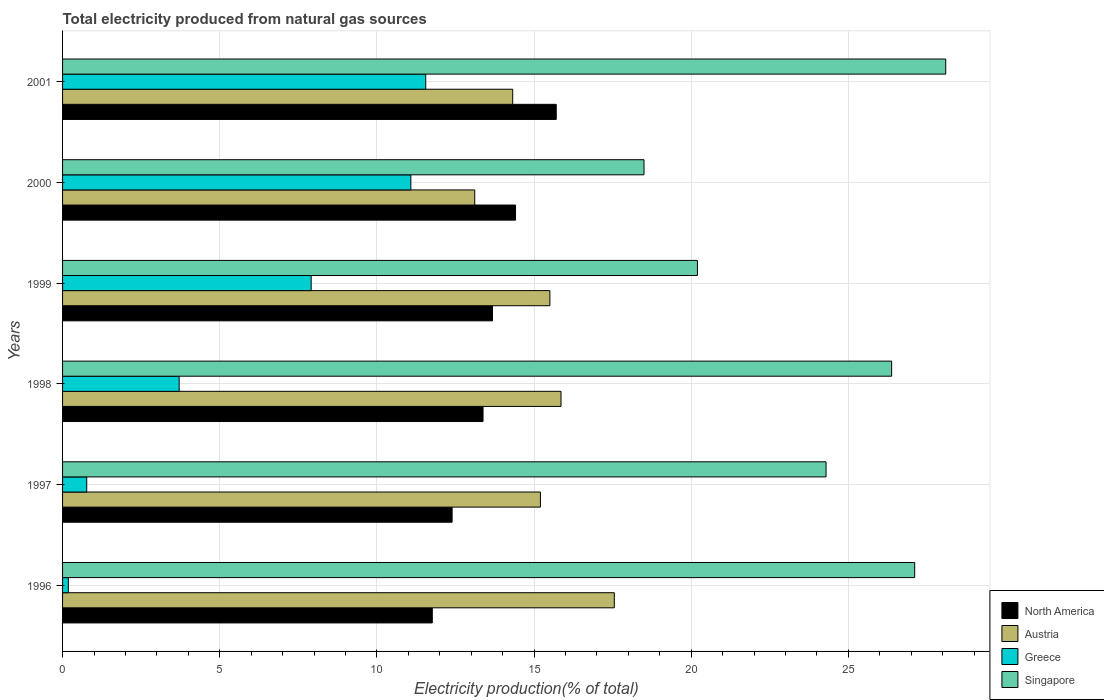How many different coloured bars are there?
Provide a succinct answer. 4. Are the number of bars per tick equal to the number of legend labels?
Offer a very short reply. Yes. Are the number of bars on each tick of the Y-axis equal?
Your answer should be compact. Yes. How many bars are there on the 6th tick from the top?
Offer a terse response. 4. What is the total electricity produced in Austria in 1996?
Provide a short and direct response. 17.56. Across all years, what is the maximum total electricity produced in Greece?
Provide a short and direct response. 11.56. Across all years, what is the minimum total electricity produced in Singapore?
Give a very brief answer. 18.5. What is the total total electricity produced in Singapore in the graph?
Your answer should be very brief. 144.58. What is the difference between the total electricity produced in Austria in 1996 and that in 1998?
Your answer should be very brief. 1.7. What is the difference between the total electricity produced in Greece in 1998 and the total electricity produced in Austria in 1999?
Provide a short and direct response. -11.8. What is the average total electricity produced in Singapore per year?
Your answer should be compact. 24.1. In the year 1998, what is the difference between the total electricity produced in Greece and total electricity produced in Singapore?
Provide a succinct answer. -22.67. In how many years, is the total electricity produced in Greece greater than 7 %?
Your answer should be compact. 3. What is the ratio of the total electricity produced in Greece in 1996 to that in 1999?
Make the answer very short. 0.02. What is the difference between the highest and the second highest total electricity produced in North America?
Offer a terse response. 1.3. What is the difference between the highest and the lowest total electricity produced in North America?
Your answer should be very brief. 3.94. In how many years, is the total electricity produced in Greece greater than the average total electricity produced in Greece taken over all years?
Your answer should be very brief. 3. Is it the case that in every year, the sum of the total electricity produced in Austria and total electricity produced in Singapore is greater than the sum of total electricity produced in North America and total electricity produced in Greece?
Your answer should be very brief. No. What does the 4th bar from the bottom in 2000 represents?
Your response must be concise. Singapore. How many bars are there?
Offer a terse response. 24. Are all the bars in the graph horizontal?
Your answer should be very brief. Yes. How many years are there in the graph?
Make the answer very short. 6. What is the difference between two consecutive major ticks on the X-axis?
Give a very brief answer. 5. Are the values on the major ticks of X-axis written in scientific E-notation?
Provide a short and direct response. No. Does the graph contain any zero values?
Offer a terse response. No. Does the graph contain grids?
Offer a very short reply. Yes. How many legend labels are there?
Provide a short and direct response. 4. How are the legend labels stacked?
Your answer should be very brief. Vertical. What is the title of the graph?
Your answer should be compact. Total electricity produced from natural gas sources. Does "High income: OECD" appear as one of the legend labels in the graph?
Your answer should be compact. No. What is the Electricity production(% of total) of North America in 1996?
Make the answer very short. 11.76. What is the Electricity production(% of total) of Austria in 1996?
Offer a very short reply. 17.56. What is the Electricity production(% of total) in Greece in 1996?
Provide a succinct answer. 0.18. What is the Electricity production(% of total) in Singapore in 1996?
Give a very brief answer. 27.11. What is the Electricity production(% of total) of North America in 1997?
Make the answer very short. 12.39. What is the Electricity production(% of total) of Austria in 1997?
Offer a very short reply. 15.2. What is the Electricity production(% of total) of Greece in 1997?
Keep it short and to the point. 0.77. What is the Electricity production(% of total) in Singapore in 1997?
Ensure brevity in your answer.  24.29. What is the Electricity production(% of total) of North America in 1998?
Your response must be concise. 13.38. What is the Electricity production(% of total) of Austria in 1998?
Offer a terse response. 15.86. What is the Electricity production(% of total) of Greece in 1998?
Keep it short and to the point. 3.71. What is the Electricity production(% of total) of Singapore in 1998?
Your answer should be compact. 26.38. What is the Electricity production(% of total) in North America in 1999?
Give a very brief answer. 13.68. What is the Electricity production(% of total) of Austria in 1999?
Your answer should be compact. 15.51. What is the Electricity production(% of total) in Greece in 1999?
Offer a very short reply. 7.91. What is the Electricity production(% of total) in Singapore in 1999?
Offer a very short reply. 20.2. What is the Electricity production(% of total) of North America in 2000?
Give a very brief answer. 14.41. What is the Electricity production(% of total) in Austria in 2000?
Your answer should be very brief. 13.11. What is the Electricity production(% of total) of Greece in 2000?
Give a very brief answer. 11.08. What is the Electricity production(% of total) of Singapore in 2000?
Ensure brevity in your answer.  18.5. What is the Electricity production(% of total) of North America in 2001?
Keep it short and to the point. 15.71. What is the Electricity production(% of total) in Austria in 2001?
Your answer should be very brief. 14.32. What is the Electricity production(% of total) of Greece in 2001?
Your response must be concise. 11.56. What is the Electricity production(% of total) in Singapore in 2001?
Provide a succinct answer. 28.1. Across all years, what is the maximum Electricity production(% of total) of North America?
Your answer should be compact. 15.71. Across all years, what is the maximum Electricity production(% of total) of Austria?
Make the answer very short. 17.56. Across all years, what is the maximum Electricity production(% of total) in Greece?
Make the answer very short. 11.56. Across all years, what is the maximum Electricity production(% of total) of Singapore?
Offer a terse response. 28.1. Across all years, what is the minimum Electricity production(% of total) of North America?
Ensure brevity in your answer.  11.76. Across all years, what is the minimum Electricity production(% of total) in Austria?
Give a very brief answer. 13.11. Across all years, what is the minimum Electricity production(% of total) of Greece?
Offer a very short reply. 0.18. Across all years, what is the minimum Electricity production(% of total) in Singapore?
Your answer should be very brief. 18.5. What is the total Electricity production(% of total) of North America in the graph?
Offer a terse response. 81.33. What is the total Electricity production(% of total) of Austria in the graph?
Your answer should be very brief. 91.56. What is the total Electricity production(% of total) of Greece in the graph?
Provide a succinct answer. 35.21. What is the total Electricity production(% of total) of Singapore in the graph?
Provide a short and direct response. 144.58. What is the difference between the Electricity production(% of total) of North America in 1996 and that in 1997?
Offer a terse response. -0.63. What is the difference between the Electricity production(% of total) of Austria in 1996 and that in 1997?
Ensure brevity in your answer.  2.35. What is the difference between the Electricity production(% of total) of Greece in 1996 and that in 1997?
Provide a short and direct response. -0.59. What is the difference between the Electricity production(% of total) in Singapore in 1996 and that in 1997?
Offer a terse response. 2.82. What is the difference between the Electricity production(% of total) of North America in 1996 and that in 1998?
Your answer should be very brief. -1.61. What is the difference between the Electricity production(% of total) of Austria in 1996 and that in 1998?
Your answer should be compact. 1.7. What is the difference between the Electricity production(% of total) of Greece in 1996 and that in 1998?
Your response must be concise. -3.53. What is the difference between the Electricity production(% of total) in Singapore in 1996 and that in 1998?
Your response must be concise. 0.73. What is the difference between the Electricity production(% of total) in North America in 1996 and that in 1999?
Provide a succinct answer. -1.92. What is the difference between the Electricity production(% of total) in Austria in 1996 and that in 1999?
Your response must be concise. 2.05. What is the difference between the Electricity production(% of total) in Greece in 1996 and that in 1999?
Provide a short and direct response. -7.73. What is the difference between the Electricity production(% of total) in Singapore in 1996 and that in 1999?
Your answer should be very brief. 6.91. What is the difference between the Electricity production(% of total) of North America in 1996 and that in 2000?
Offer a very short reply. -2.65. What is the difference between the Electricity production(% of total) of Austria in 1996 and that in 2000?
Make the answer very short. 4.44. What is the difference between the Electricity production(% of total) of Greece in 1996 and that in 2000?
Offer a terse response. -10.9. What is the difference between the Electricity production(% of total) of Singapore in 1996 and that in 2000?
Ensure brevity in your answer.  8.61. What is the difference between the Electricity production(% of total) of North America in 1996 and that in 2001?
Keep it short and to the point. -3.94. What is the difference between the Electricity production(% of total) in Austria in 1996 and that in 2001?
Offer a very short reply. 3.23. What is the difference between the Electricity production(% of total) in Greece in 1996 and that in 2001?
Offer a very short reply. -11.37. What is the difference between the Electricity production(% of total) in Singapore in 1996 and that in 2001?
Give a very brief answer. -0.99. What is the difference between the Electricity production(% of total) in North America in 1997 and that in 1998?
Offer a terse response. -0.98. What is the difference between the Electricity production(% of total) of Austria in 1997 and that in 1998?
Ensure brevity in your answer.  -0.66. What is the difference between the Electricity production(% of total) of Greece in 1997 and that in 1998?
Give a very brief answer. -2.94. What is the difference between the Electricity production(% of total) in Singapore in 1997 and that in 1998?
Offer a terse response. -2.09. What is the difference between the Electricity production(% of total) in North America in 1997 and that in 1999?
Make the answer very short. -1.29. What is the difference between the Electricity production(% of total) in Austria in 1997 and that in 1999?
Offer a terse response. -0.3. What is the difference between the Electricity production(% of total) in Greece in 1997 and that in 1999?
Offer a very short reply. -7.14. What is the difference between the Electricity production(% of total) of Singapore in 1997 and that in 1999?
Provide a succinct answer. 4.09. What is the difference between the Electricity production(% of total) of North America in 1997 and that in 2000?
Keep it short and to the point. -2.02. What is the difference between the Electricity production(% of total) of Austria in 1997 and that in 2000?
Keep it short and to the point. 2.09. What is the difference between the Electricity production(% of total) in Greece in 1997 and that in 2000?
Provide a short and direct response. -10.31. What is the difference between the Electricity production(% of total) of Singapore in 1997 and that in 2000?
Your response must be concise. 5.79. What is the difference between the Electricity production(% of total) in North America in 1997 and that in 2001?
Provide a succinct answer. -3.31. What is the difference between the Electricity production(% of total) of Austria in 1997 and that in 2001?
Keep it short and to the point. 0.88. What is the difference between the Electricity production(% of total) of Greece in 1997 and that in 2001?
Keep it short and to the point. -10.79. What is the difference between the Electricity production(% of total) in Singapore in 1997 and that in 2001?
Ensure brevity in your answer.  -3.81. What is the difference between the Electricity production(% of total) of North America in 1998 and that in 1999?
Your answer should be very brief. -0.3. What is the difference between the Electricity production(% of total) of Austria in 1998 and that in 1999?
Offer a very short reply. 0.35. What is the difference between the Electricity production(% of total) in Greece in 1998 and that in 1999?
Provide a short and direct response. -4.2. What is the difference between the Electricity production(% of total) of Singapore in 1998 and that in 1999?
Your answer should be compact. 6.18. What is the difference between the Electricity production(% of total) in North America in 1998 and that in 2000?
Offer a terse response. -1.03. What is the difference between the Electricity production(% of total) in Austria in 1998 and that in 2000?
Provide a succinct answer. 2.75. What is the difference between the Electricity production(% of total) of Greece in 1998 and that in 2000?
Your response must be concise. -7.37. What is the difference between the Electricity production(% of total) in Singapore in 1998 and that in 2000?
Your answer should be compact. 7.88. What is the difference between the Electricity production(% of total) of North America in 1998 and that in 2001?
Provide a succinct answer. -2.33. What is the difference between the Electricity production(% of total) of Austria in 1998 and that in 2001?
Make the answer very short. 1.54. What is the difference between the Electricity production(% of total) in Greece in 1998 and that in 2001?
Offer a terse response. -7.85. What is the difference between the Electricity production(% of total) in Singapore in 1998 and that in 2001?
Keep it short and to the point. -1.72. What is the difference between the Electricity production(% of total) in North America in 1999 and that in 2000?
Ensure brevity in your answer.  -0.73. What is the difference between the Electricity production(% of total) of Austria in 1999 and that in 2000?
Ensure brevity in your answer.  2.39. What is the difference between the Electricity production(% of total) of Greece in 1999 and that in 2000?
Offer a very short reply. -3.17. What is the difference between the Electricity production(% of total) of Singapore in 1999 and that in 2000?
Keep it short and to the point. 1.7. What is the difference between the Electricity production(% of total) of North America in 1999 and that in 2001?
Ensure brevity in your answer.  -2.03. What is the difference between the Electricity production(% of total) of Austria in 1999 and that in 2001?
Ensure brevity in your answer.  1.18. What is the difference between the Electricity production(% of total) in Greece in 1999 and that in 2001?
Your answer should be very brief. -3.65. What is the difference between the Electricity production(% of total) in Singapore in 1999 and that in 2001?
Provide a short and direct response. -7.9. What is the difference between the Electricity production(% of total) in North America in 2000 and that in 2001?
Give a very brief answer. -1.3. What is the difference between the Electricity production(% of total) in Austria in 2000 and that in 2001?
Your response must be concise. -1.21. What is the difference between the Electricity production(% of total) in Greece in 2000 and that in 2001?
Your answer should be very brief. -0.47. What is the difference between the Electricity production(% of total) of Singapore in 2000 and that in 2001?
Ensure brevity in your answer.  -9.6. What is the difference between the Electricity production(% of total) of North America in 1996 and the Electricity production(% of total) of Austria in 1997?
Keep it short and to the point. -3.44. What is the difference between the Electricity production(% of total) in North America in 1996 and the Electricity production(% of total) in Greece in 1997?
Make the answer very short. 10.99. What is the difference between the Electricity production(% of total) of North America in 1996 and the Electricity production(% of total) of Singapore in 1997?
Give a very brief answer. -12.53. What is the difference between the Electricity production(% of total) in Austria in 1996 and the Electricity production(% of total) in Greece in 1997?
Your answer should be compact. 16.79. What is the difference between the Electricity production(% of total) in Austria in 1996 and the Electricity production(% of total) in Singapore in 1997?
Provide a short and direct response. -6.74. What is the difference between the Electricity production(% of total) in Greece in 1996 and the Electricity production(% of total) in Singapore in 1997?
Give a very brief answer. -24.11. What is the difference between the Electricity production(% of total) of North America in 1996 and the Electricity production(% of total) of Austria in 1998?
Offer a very short reply. -4.1. What is the difference between the Electricity production(% of total) in North America in 1996 and the Electricity production(% of total) in Greece in 1998?
Make the answer very short. 8.05. What is the difference between the Electricity production(% of total) of North America in 1996 and the Electricity production(% of total) of Singapore in 1998?
Give a very brief answer. -14.62. What is the difference between the Electricity production(% of total) in Austria in 1996 and the Electricity production(% of total) in Greece in 1998?
Offer a very short reply. 13.85. What is the difference between the Electricity production(% of total) in Austria in 1996 and the Electricity production(% of total) in Singapore in 1998?
Provide a succinct answer. -8.82. What is the difference between the Electricity production(% of total) of Greece in 1996 and the Electricity production(% of total) of Singapore in 1998?
Keep it short and to the point. -26.19. What is the difference between the Electricity production(% of total) of North America in 1996 and the Electricity production(% of total) of Austria in 1999?
Ensure brevity in your answer.  -3.74. What is the difference between the Electricity production(% of total) in North America in 1996 and the Electricity production(% of total) in Greece in 1999?
Your answer should be compact. 3.85. What is the difference between the Electricity production(% of total) in North America in 1996 and the Electricity production(% of total) in Singapore in 1999?
Ensure brevity in your answer.  -8.44. What is the difference between the Electricity production(% of total) of Austria in 1996 and the Electricity production(% of total) of Greece in 1999?
Keep it short and to the point. 9.65. What is the difference between the Electricity production(% of total) of Austria in 1996 and the Electricity production(% of total) of Singapore in 1999?
Ensure brevity in your answer.  -2.64. What is the difference between the Electricity production(% of total) of Greece in 1996 and the Electricity production(% of total) of Singapore in 1999?
Your response must be concise. -20.02. What is the difference between the Electricity production(% of total) in North America in 1996 and the Electricity production(% of total) in Austria in 2000?
Ensure brevity in your answer.  -1.35. What is the difference between the Electricity production(% of total) of North America in 1996 and the Electricity production(% of total) of Greece in 2000?
Make the answer very short. 0.68. What is the difference between the Electricity production(% of total) in North America in 1996 and the Electricity production(% of total) in Singapore in 2000?
Offer a very short reply. -6.74. What is the difference between the Electricity production(% of total) in Austria in 1996 and the Electricity production(% of total) in Greece in 2000?
Offer a terse response. 6.47. What is the difference between the Electricity production(% of total) of Austria in 1996 and the Electricity production(% of total) of Singapore in 2000?
Provide a succinct answer. -0.94. What is the difference between the Electricity production(% of total) in Greece in 1996 and the Electricity production(% of total) in Singapore in 2000?
Offer a very short reply. -18.32. What is the difference between the Electricity production(% of total) of North America in 1996 and the Electricity production(% of total) of Austria in 2001?
Provide a short and direct response. -2.56. What is the difference between the Electricity production(% of total) in North America in 1996 and the Electricity production(% of total) in Greece in 2001?
Ensure brevity in your answer.  0.21. What is the difference between the Electricity production(% of total) of North America in 1996 and the Electricity production(% of total) of Singapore in 2001?
Provide a succinct answer. -16.34. What is the difference between the Electricity production(% of total) in Austria in 1996 and the Electricity production(% of total) in Greece in 2001?
Your answer should be compact. 6. What is the difference between the Electricity production(% of total) of Austria in 1996 and the Electricity production(% of total) of Singapore in 2001?
Your answer should be compact. -10.54. What is the difference between the Electricity production(% of total) of Greece in 1996 and the Electricity production(% of total) of Singapore in 2001?
Your answer should be very brief. -27.92. What is the difference between the Electricity production(% of total) in North America in 1997 and the Electricity production(% of total) in Austria in 1998?
Provide a succinct answer. -3.47. What is the difference between the Electricity production(% of total) in North America in 1997 and the Electricity production(% of total) in Greece in 1998?
Provide a succinct answer. 8.68. What is the difference between the Electricity production(% of total) of North America in 1997 and the Electricity production(% of total) of Singapore in 1998?
Offer a terse response. -13.98. What is the difference between the Electricity production(% of total) of Austria in 1997 and the Electricity production(% of total) of Greece in 1998?
Ensure brevity in your answer.  11.49. What is the difference between the Electricity production(% of total) in Austria in 1997 and the Electricity production(% of total) in Singapore in 1998?
Provide a succinct answer. -11.18. What is the difference between the Electricity production(% of total) of Greece in 1997 and the Electricity production(% of total) of Singapore in 1998?
Provide a short and direct response. -25.61. What is the difference between the Electricity production(% of total) in North America in 1997 and the Electricity production(% of total) in Austria in 1999?
Your answer should be very brief. -3.11. What is the difference between the Electricity production(% of total) of North America in 1997 and the Electricity production(% of total) of Greece in 1999?
Ensure brevity in your answer.  4.48. What is the difference between the Electricity production(% of total) of North America in 1997 and the Electricity production(% of total) of Singapore in 1999?
Provide a succinct answer. -7.81. What is the difference between the Electricity production(% of total) in Austria in 1997 and the Electricity production(% of total) in Greece in 1999?
Give a very brief answer. 7.29. What is the difference between the Electricity production(% of total) in Austria in 1997 and the Electricity production(% of total) in Singapore in 1999?
Make the answer very short. -5. What is the difference between the Electricity production(% of total) of Greece in 1997 and the Electricity production(% of total) of Singapore in 1999?
Provide a short and direct response. -19.43. What is the difference between the Electricity production(% of total) in North America in 1997 and the Electricity production(% of total) in Austria in 2000?
Make the answer very short. -0.72. What is the difference between the Electricity production(% of total) in North America in 1997 and the Electricity production(% of total) in Greece in 2000?
Provide a succinct answer. 1.31. What is the difference between the Electricity production(% of total) of North America in 1997 and the Electricity production(% of total) of Singapore in 2000?
Your answer should be very brief. -6.11. What is the difference between the Electricity production(% of total) in Austria in 1997 and the Electricity production(% of total) in Greece in 2000?
Ensure brevity in your answer.  4.12. What is the difference between the Electricity production(% of total) in Austria in 1997 and the Electricity production(% of total) in Singapore in 2000?
Offer a very short reply. -3.3. What is the difference between the Electricity production(% of total) of Greece in 1997 and the Electricity production(% of total) of Singapore in 2000?
Make the answer very short. -17.73. What is the difference between the Electricity production(% of total) of North America in 1997 and the Electricity production(% of total) of Austria in 2001?
Provide a succinct answer. -1.93. What is the difference between the Electricity production(% of total) of North America in 1997 and the Electricity production(% of total) of Greece in 2001?
Your answer should be compact. 0.84. What is the difference between the Electricity production(% of total) of North America in 1997 and the Electricity production(% of total) of Singapore in 2001?
Offer a terse response. -15.71. What is the difference between the Electricity production(% of total) of Austria in 1997 and the Electricity production(% of total) of Greece in 2001?
Keep it short and to the point. 3.65. What is the difference between the Electricity production(% of total) in Austria in 1997 and the Electricity production(% of total) in Singapore in 2001?
Your response must be concise. -12.9. What is the difference between the Electricity production(% of total) in Greece in 1997 and the Electricity production(% of total) in Singapore in 2001?
Your response must be concise. -27.33. What is the difference between the Electricity production(% of total) in North America in 1998 and the Electricity production(% of total) in Austria in 1999?
Make the answer very short. -2.13. What is the difference between the Electricity production(% of total) in North America in 1998 and the Electricity production(% of total) in Greece in 1999?
Offer a very short reply. 5.47. What is the difference between the Electricity production(% of total) in North America in 1998 and the Electricity production(% of total) in Singapore in 1999?
Provide a succinct answer. -6.82. What is the difference between the Electricity production(% of total) of Austria in 1998 and the Electricity production(% of total) of Greece in 1999?
Provide a short and direct response. 7.95. What is the difference between the Electricity production(% of total) in Austria in 1998 and the Electricity production(% of total) in Singapore in 1999?
Make the answer very short. -4.34. What is the difference between the Electricity production(% of total) of Greece in 1998 and the Electricity production(% of total) of Singapore in 1999?
Keep it short and to the point. -16.49. What is the difference between the Electricity production(% of total) in North America in 1998 and the Electricity production(% of total) in Austria in 2000?
Ensure brevity in your answer.  0.26. What is the difference between the Electricity production(% of total) in North America in 1998 and the Electricity production(% of total) in Greece in 2000?
Ensure brevity in your answer.  2.3. What is the difference between the Electricity production(% of total) of North America in 1998 and the Electricity production(% of total) of Singapore in 2000?
Make the answer very short. -5.12. What is the difference between the Electricity production(% of total) in Austria in 1998 and the Electricity production(% of total) in Greece in 2000?
Provide a succinct answer. 4.78. What is the difference between the Electricity production(% of total) in Austria in 1998 and the Electricity production(% of total) in Singapore in 2000?
Offer a very short reply. -2.64. What is the difference between the Electricity production(% of total) in Greece in 1998 and the Electricity production(% of total) in Singapore in 2000?
Provide a succinct answer. -14.79. What is the difference between the Electricity production(% of total) of North America in 1998 and the Electricity production(% of total) of Austria in 2001?
Provide a succinct answer. -0.94. What is the difference between the Electricity production(% of total) of North America in 1998 and the Electricity production(% of total) of Greece in 2001?
Keep it short and to the point. 1.82. What is the difference between the Electricity production(% of total) in North America in 1998 and the Electricity production(% of total) in Singapore in 2001?
Your response must be concise. -14.72. What is the difference between the Electricity production(% of total) in Austria in 1998 and the Electricity production(% of total) in Greece in 2001?
Make the answer very short. 4.3. What is the difference between the Electricity production(% of total) in Austria in 1998 and the Electricity production(% of total) in Singapore in 2001?
Offer a very short reply. -12.24. What is the difference between the Electricity production(% of total) of Greece in 1998 and the Electricity production(% of total) of Singapore in 2001?
Ensure brevity in your answer.  -24.39. What is the difference between the Electricity production(% of total) of North America in 1999 and the Electricity production(% of total) of Austria in 2000?
Keep it short and to the point. 0.57. What is the difference between the Electricity production(% of total) of North America in 1999 and the Electricity production(% of total) of Greece in 2000?
Make the answer very short. 2.6. What is the difference between the Electricity production(% of total) of North America in 1999 and the Electricity production(% of total) of Singapore in 2000?
Offer a very short reply. -4.82. What is the difference between the Electricity production(% of total) in Austria in 1999 and the Electricity production(% of total) in Greece in 2000?
Your answer should be very brief. 4.42. What is the difference between the Electricity production(% of total) of Austria in 1999 and the Electricity production(% of total) of Singapore in 2000?
Your answer should be very brief. -2.99. What is the difference between the Electricity production(% of total) in Greece in 1999 and the Electricity production(% of total) in Singapore in 2000?
Offer a terse response. -10.59. What is the difference between the Electricity production(% of total) in North America in 1999 and the Electricity production(% of total) in Austria in 2001?
Keep it short and to the point. -0.64. What is the difference between the Electricity production(% of total) of North America in 1999 and the Electricity production(% of total) of Greece in 2001?
Give a very brief answer. 2.12. What is the difference between the Electricity production(% of total) of North America in 1999 and the Electricity production(% of total) of Singapore in 2001?
Ensure brevity in your answer.  -14.42. What is the difference between the Electricity production(% of total) of Austria in 1999 and the Electricity production(% of total) of Greece in 2001?
Your response must be concise. 3.95. What is the difference between the Electricity production(% of total) of Austria in 1999 and the Electricity production(% of total) of Singapore in 2001?
Provide a short and direct response. -12.59. What is the difference between the Electricity production(% of total) of Greece in 1999 and the Electricity production(% of total) of Singapore in 2001?
Make the answer very short. -20.19. What is the difference between the Electricity production(% of total) in North America in 2000 and the Electricity production(% of total) in Austria in 2001?
Make the answer very short. 0.09. What is the difference between the Electricity production(% of total) in North America in 2000 and the Electricity production(% of total) in Greece in 2001?
Keep it short and to the point. 2.86. What is the difference between the Electricity production(% of total) of North America in 2000 and the Electricity production(% of total) of Singapore in 2001?
Keep it short and to the point. -13.69. What is the difference between the Electricity production(% of total) in Austria in 2000 and the Electricity production(% of total) in Greece in 2001?
Give a very brief answer. 1.56. What is the difference between the Electricity production(% of total) in Austria in 2000 and the Electricity production(% of total) in Singapore in 2001?
Give a very brief answer. -14.99. What is the difference between the Electricity production(% of total) in Greece in 2000 and the Electricity production(% of total) in Singapore in 2001?
Your answer should be very brief. -17.02. What is the average Electricity production(% of total) of North America per year?
Provide a succinct answer. 13.56. What is the average Electricity production(% of total) in Austria per year?
Provide a succinct answer. 15.26. What is the average Electricity production(% of total) of Greece per year?
Give a very brief answer. 5.87. What is the average Electricity production(% of total) of Singapore per year?
Ensure brevity in your answer.  24.1. In the year 1996, what is the difference between the Electricity production(% of total) in North America and Electricity production(% of total) in Austria?
Provide a short and direct response. -5.79. In the year 1996, what is the difference between the Electricity production(% of total) of North America and Electricity production(% of total) of Greece?
Keep it short and to the point. 11.58. In the year 1996, what is the difference between the Electricity production(% of total) of North America and Electricity production(% of total) of Singapore?
Your answer should be very brief. -15.35. In the year 1996, what is the difference between the Electricity production(% of total) in Austria and Electricity production(% of total) in Greece?
Your answer should be compact. 17.37. In the year 1996, what is the difference between the Electricity production(% of total) in Austria and Electricity production(% of total) in Singapore?
Your answer should be very brief. -9.56. In the year 1996, what is the difference between the Electricity production(% of total) of Greece and Electricity production(% of total) of Singapore?
Your answer should be very brief. -26.93. In the year 1997, what is the difference between the Electricity production(% of total) in North America and Electricity production(% of total) in Austria?
Your answer should be compact. -2.81. In the year 1997, what is the difference between the Electricity production(% of total) in North America and Electricity production(% of total) in Greece?
Provide a short and direct response. 11.62. In the year 1997, what is the difference between the Electricity production(% of total) of North America and Electricity production(% of total) of Singapore?
Make the answer very short. -11.9. In the year 1997, what is the difference between the Electricity production(% of total) in Austria and Electricity production(% of total) in Greece?
Your response must be concise. 14.43. In the year 1997, what is the difference between the Electricity production(% of total) in Austria and Electricity production(% of total) in Singapore?
Keep it short and to the point. -9.09. In the year 1997, what is the difference between the Electricity production(% of total) in Greece and Electricity production(% of total) in Singapore?
Provide a short and direct response. -23.52. In the year 1998, what is the difference between the Electricity production(% of total) of North America and Electricity production(% of total) of Austria?
Offer a terse response. -2.48. In the year 1998, what is the difference between the Electricity production(% of total) in North America and Electricity production(% of total) in Greece?
Offer a very short reply. 9.67. In the year 1998, what is the difference between the Electricity production(% of total) in North America and Electricity production(% of total) in Singapore?
Provide a short and direct response. -13. In the year 1998, what is the difference between the Electricity production(% of total) of Austria and Electricity production(% of total) of Greece?
Make the answer very short. 12.15. In the year 1998, what is the difference between the Electricity production(% of total) in Austria and Electricity production(% of total) in Singapore?
Make the answer very short. -10.52. In the year 1998, what is the difference between the Electricity production(% of total) in Greece and Electricity production(% of total) in Singapore?
Ensure brevity in your answer.  -22.67. In the year 1999, what is the difference between the Electricity production(% of total) in North America and Electricity production(% of total) in Austria?
Provide a short and direct response. -1.83. In the year 1999, what is the difference between the Electricity production(% of total) in North America and Electricity production(% of total) in Greece?
Offer a terse response. 5.77. In the year 1999, what is the difference between the Electricity production(% of total) of North America and Electricity production(% of total) of Singapore?
Offer a terse response. -6.52. In the year 1999, what is the difference between the Electricity production(% of total) in Austria and Electricity production(% of total) in Greece?
Give a very brief answer. 7.6. In the year 1999, what is the difference between the Electricity production(% of total) of Austria and Electricity production(% of total) of Singapore?
Your answer should be very brief. -4.69. In the year 1999, what is the difference between the Electricity production(% of total) in Greece and Electricity production(% of total) in Singapore?
Offer a very short reply. -12.29. In the year 2000, what is the difference between the Electricity production(% of total) of North America and Electricity production(% of total) of Austria?
Give a very brief answer. 1.3. In the year 2000, what is the difference between the Electricity production(% of total) in North America and Electricity production(% of total) in Greece?
Make the answer very short. 3.33. In the year 2000, what is the difference between the Electricity production(% of total) in North America and Electricity production(% of total) in Singapore?
Offer a terse response. -4.09. In the year 2000, what is the difference between the Electricity production(% of total) of Austria and Electricity production(% of total) of Greece?
Keep it short and to the point. 2.03. In the year 2000, what is the difference between the Electricity production(% of total) in Austria and Electricity production(% of total) in Singapore?
Offer a terse response. -5.39. In the year 2000, what is the difference between the Electricity production(% of total) in Greece and Electricity production(% of total) in Singapore?
Provide a succinct answer. -7.42. In the year 2001, what is the difference between the Electricity production(% of total) in North America and Electricity production(% of total) in Austria?
Make the answer very short. 1.39. In the year 2001, what is the difference between the Electricity production(% of total) in North America and Electricity production(% of total) in Greece?
Ensure brevity in your answer.  4.15. In the year 2001, what is the difference between the Electricity production(% of total) of North America and Electricity production(% of total) of Singapore?
Your response must be concise. -12.39. In the year 2001, what is the difference between the Electricity production(% of total) of Austria and Electricity production(% of total) of Greece?
Offer a terse response. 2.77. In the year 2001, what is the difference between the Electricity production(% of total) in Austria and Electricity production(% of total) in Singapore?
Offer a terse response. -13.78. In the year 2001, what is the difference between the Electricity production(% of total) of Greece and Electricity production(% of total) of Singapore?
Make the answer very short. -16.54. What is the ratio of the Electricity production(% of total) in North America in 1996 to that in 1997?
Make the answer very short. 0.95. What is the ratio of the Electricity production(% of total) in Austria in 1996 to that in 1997?
Give a very brief answer. 1.15. What is the ratio of the Electricity production(% of total) of Greece in 1996 to that in 1997?
Provide a succinct answer. 0.24. What is the ratio of the Electricity production(% of total) of Singapore in 1996 to that in 1997?
Offer a terse response. 1.12. What is the ratio of the Electricity production(% of total) in North America in 1996 to that in 1998?
Provide a succinct answer. 0.88. What is the ratio of the Electricity production(% of total) of Austria in 1996 to that in 1998?
Give a very brief answer. 1.11. What is the ratio of the Electricity production(% of total) of Greece in 1996 to that in 1998?
Your response must be concise. 0.05. What is the ratio of the Electricity production(% of total) of Singapore in 1996 to that in 1998?
Give a very brief answer. 1.03. What is the ratio of the Electricity production(% of total) in North America in 1996 to that in 1999?
Provide a short and direct response. 0.86. What is the ratio of the Electricity production(% of total) of Austria in 1996 to that in 1999?
Ensure brevity in your answer.  1.13. What is the ratio of the Electricity production(% of total) of Greece in 1996 to that in 1999?
Ensure brevity in your answer.  0.02. What is the ratio of the Electricity production(% of total) in Singapore in 1996 to that in 1999?
Provide a short and direct response. 1.34. What is the ratio of the Electricity production(% of total) in North America in 1996 to that in 2000?
Offer a very short reply. 0.82. What is the ratio of the Electricity production(% of total) in Austria in 1996 to that in 2000?
Your answer should be compact. 1.34. What is the ratio of the Electricity production(% of total) in Greece in 1996 to that in 2000?
Keep it short and to the point. 0.02. What is the ratio of the Electricity production(% of total) of Singapore in 1996 to that in 2000?
Your answer should be very brief. 1.47. What is the ratio of the Electricity production(% of total) of North America in 1996 to that in 2001?
Offer a very short reply. 0.75. What is the ratio of the Electricity production(% of total) of Austria in 1996 to that in 2001?
Keep it short and to the point. 1.23. What is the ratio of the Electricity production(% of total) in Greece in 1996 to that in 2001?
Make the answer very short. 0.02. What is the ratio of the Electricity production(% of total) in Singapore in 1996 to that in 2001?
Keep it short and to the point. 0.96. What is the ratio of the Electricity production(% of total) of North America in 1997 to that in 1998?
Your response must be concise. 0.93. What is the ratio of the Electricity production(% of total) in Austria in 1997 to that in 1998?
Offer a very short reply. 0.96. What is the ratio of the Electricity production(% of total) in Greece in 1997 to that in 1998?
Make the answer very short. 0.21. What is the ratio of the Electricity production(% of total) of Singapore in 1997 to that in 1998?
Ensure brevity in your answer.  0.92. What is the ratio of the Electricity production(% of total) of North America in 1997 to that in 1999?
Your answer should be very brief. 0.91. What is the ratio of the Electricity production(% of total) in Austria in 1997 to that in 1999?
Your response must be concise. 0.98. What is the ratio of the Electricity production(% of total) of Greece in 1997 to that in 1999?
Your answer should be very brief. 0.1. What is the ratio of the Electricity production(% of total) in Singapore in 1997 to that in 1999?
Give a very brief answer. 1.2. What is the ratio of the Electricity production(% of total) of North America in 1997 to that in 2000?
Make the answer very short. 0.86. What is the ratio of the Electricity production(% of total) in Austria in 1997 to that in 2000?
Keep it short and to the point. 1.16. What is the ratio of the Electricity production(% of total) in Greece in 1997 to that in 2000?
Give a very brief answer. 0.07. What is the ratio of the Electricity production(% of total) in Singapore in 1997 to that in 2000?
Offer a terse response. 1.31. What is the ratio of the Electricity production(% of total) in North America in 1997 to that in 2001?
Your answer should be very brief. 0.79. What is the ratio of the Electricity production(% of total) in Austria in 1997 to that in 2001?
Offer a terse response. 1.06. What is the ratio of the Electricity production(% of total) of Greece in 1997 to that in 2001?
Provide a succinct answer. 0.07. What is the ratio of the Electricity production(% of total) in Singapore in 1997 to that in 2001?
Ensure brevity in your answer.  0.86. What is the ratio of the Electricity production(% of total) of North America in 1998 to that in 1999?
Offer a terse response. 0.98. What is the ratio of the Electricity production(% of total) in Austria in 1998 to that in 1999?
Make the answer very short. 1.02. What is the ratio of the Electricity production(% of total) of Greece in 1998 to that in 1999?
Give a very brief answer. 0.47. What is the ratio of the Electricity production(% of total) of Singapore in 1998 to that in 1999?
Your response must be concise. 1.31. What is the ratio of the Electricity production(% of total) in North America in 1998 to that in 2000?
Make the answer very short. 0.93. What is the ratio of the Electricity production(% of total) in Austria in 1998 to that in 2000?
Your answer should be compact. 1.21. What is the ratio of the Electricity production(% of total) in Greece in 1998 to that in 2000?
Ensure brevity in your answer.  0.33. What is the ratio of the Electricity production(% of total) of Singapore in 1998 to that in 2000?
Provide a succinct answer. 1.43. What is the ratio of the Electricity production(% of total) in North America in 1998 to that in 2001?
Your response must be concise. 0.85. What is the ratio of the Electricity production(% of total) of Austria in 1998 to that in 2001?
Your response must be concise. 1.11. What is the ratio of the Electricity production(% of total) in Greece in 1998 to that in 2001?
Give a very brief answer. 0.32. What is the ratio of the Electricity production(% of total) of Singapore in 1998 to that in 2001?
Offer a terse response. 0.94. What is the ratio of the Electricity production(% of total) in North America in 1999 to that in 2000?
Your response must be concise. 0.95. What is the ratio of the Electricity production(% of total) of Austria in 1999 to that in 2000?
Offer a very short reply. 1.18. What is the ratio of the Electricity production(% of total) in Greece in 1999 to that in 2000?
Provide a succinct answer. 0.71. What is the ratio of the Electricity production(% of total) in Singapore in 1999 to that in 2000?
Provide a succinct answer. 1.09. What is the ratio of the Electricity production(% of total) in North America in 1999 to that in 2001?
Ensure brevity in your answer.  0.87. What is the ratio of the Electricity production(% of total) in Austria in 1999 to that in 2001?
Your answer should be very brief. 1.08. What is the ratio of the Electricity production(% of total) in Greece in 1999 to that in 2001?
Your response must be concise. 0.68. What is the ratio of the Electricity production(% of total) of Singapore in 1999 to that in 2001?
Keep it short and to the point. 0.72. What is the ratio of the Electricity production(% of total) of North America in 2000 to that in 2001?
Give a very brief answer. 0.92. What is the ratio of the Electricity production(% of total) in Austria in 2000 to that in 2001?
Your answer should be very brief. 0.92. What is the ratio of the Electricity production(% of total) in Greece in 2000 to that in 2001?
Offer a terse response. 0.96. What is the ratio of the Electricity production(% of total) in Singapore in 2000 to that in 2001?
Your answer should be very brief. 0.66. What is the difference between the highest and the second highest Electricity production(% of total) in North America?
Ensure brevity in your answer.  1.3. What is the difference between the highest and the second highest Electricity production(% of total) in Austria?
Offer a very short reply. 1.7. What is the difference between the highest and the second highest Electricity production(% of total) of Greece?
Give a very brief answer. 0.47. What is the difference between the highest and the second highest Electricity production(% of total) of Singapore?
Your response must be concise. 0.99. What is the difference between the highest and the lowest Electricity production(% of total) in North America?
Provide a short and direct response. 3.94. What is the difference between the highest and the lowest Electricity production(% of total) in Austria?
Your answer should be very brief. 4.44. What is the difference between the highest and the lowest Electricity production(% of total) of Greece?
Your response must be concise. 11.37. What is the difference between the highest and the lowest Electricity production(% of total) in Singapore?
Your answer should be very brief. 9.6. 